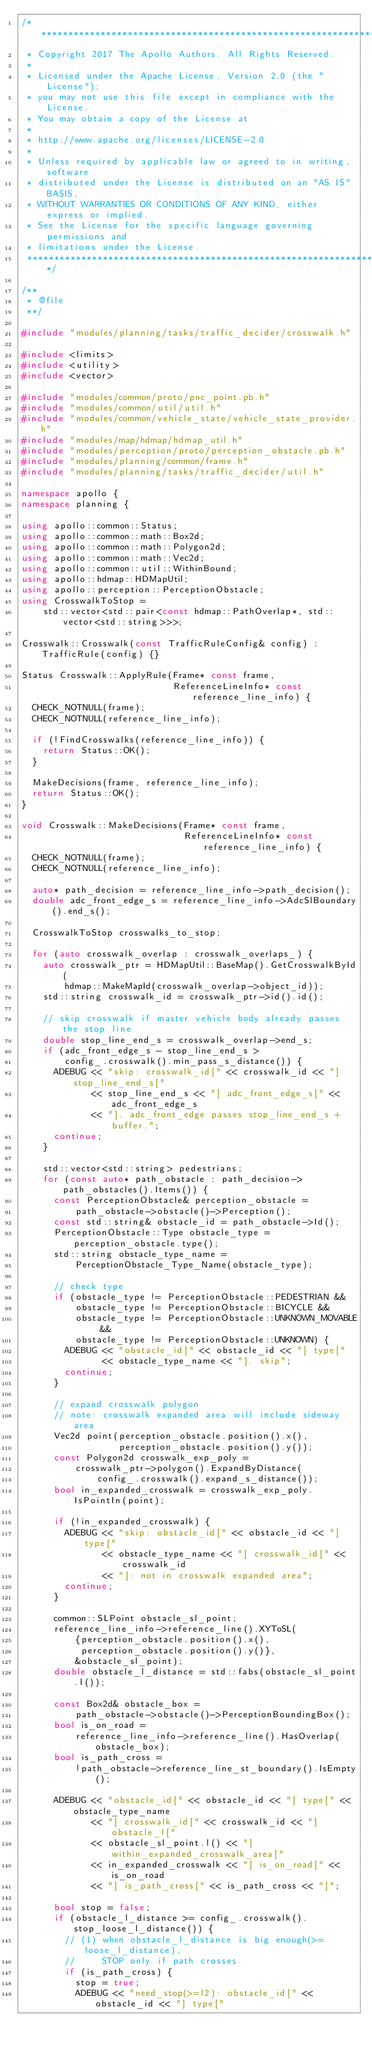Convert code to text. <code><loc_0><loc_0><loc_500><loc_500><_C++_>/******************************************************************************
 * Copyright 2017 The Apollo Authors. All Rights Reserved.
 *
 * Licensed under the Apache License, Version 2.0 (the "License");
 * you may not use this file except in compliance with the License.
 * You may obtain a copy of the License at
 *
 * http://www.apache.org/licenses/LICENSE-2.0
 *
 * Unless required by applicable law or agreed to in writing, software
 * distributed under the License is distributed on an "AS IS" BASIS,
 * WITHOUT WARRANTIES OR CONDITIONS OF ANY KIND, either express or implied.
 * See the License for the specific language governing permissions and
 * limitations under the License.
 *****************************************************************************/

/**
 * @file
 **/

#include "modules/planning/tasks/traffic_decider/crosswalk.h"

#include <limits>
#include <utility>
#include <vector>

#include "modules/common/proto/pnc_point.pb.h"
#include "modules/common/util/util.h"
#include "modules/common/vehicle_state/vehicle_state_provider.h"
#include "modules/map/hdmap/hdmap_util.h"
#include "modules/perception/proto/perception_obstacle.pb.h"
#include "modules/planning/common/frame.h"
#include "modules/planning/tasks/traffic_decider/util.h"

namespace apollo {
namespace planning {

using apollo::common::Status;
using apollo::common::math::Box2d;
using apollo::common::math::Polygon2d;
using apollo::common::math::Vec2d;
using apollo::common::util::WithinBound;
using apollo::hdmap::HDMapUtil;
using apollo::perception::PerceptionObstacle;
using CrosswalkToStop =
    std::vector<std::pair<const hdmap::PathOverlap*, std::vector<std::string>>>;

Crosswalk::Crosswalk(const TrafficRuleConfig& config) : TrafficRule(config) {}

Status Crosswalk::ApplyRule(Frame* const frame,
                            ReferenceLineInfo* const reference_line_info) {
  CHECK_NOTNULL(frame);
  CHECK_NOTNULL(reference_line_info);

  if (!FindCrosswalks(reference_line_info)) {
    return Status::OK();
  }

  MakeDecisions(frame, reference_line_info);
  return Status::OK();
}

void Crosswalk::MakeDecisions(Frame* const frame,
                              ReferenceLineInfo* const reference_line_info) {
  CHECK_NOTNULL(frame);
  CHECK_NOTNULL(reference_line_info);

  auto* path_decision = reference_line_info->path_decision();
  double adc_front_edge_s = reference_line_info->AdcSlBoundary().end_s();

  CrosswalkToStop crosswalks_to_stop;

  for (auto crosswalk_overlap : crosswalk_overlaps_) {
    auto crosswalk_ptr = HDMapUtil::BaseMap().GetCrosswalkById(
        hdmap::MakeMapId(crosswalk_overlap->object_id));
    std::string crosswalk_id = crosswalk_ptr->id().id();

    // skip crosswalk if master vehicle body already passes the stop line
    double stop_line_end_s = crosswalk_overlap->end_s;
    if (adc_front_edge_s - stop_line_end_s >
        config_.crosswalk().min_pass_s_distance()) {
      ADEBUG << "skip: crosswalk_id[" << crosswalk_id << "] stop_line_end_s["
             << stop_line_end_s << "] adc_front_edge_s[" << adc_front_edge_s
             << "]. adc_front_edge passes stop_line_end_s + buffer.";
      continue;
    }

    std::vector<std::string> pedestrians;
    for (const auto* path_obstacle : path_decision->path_obstacles().Items()) {
      const PerceptionObstacle& perception_obstacle =
          path_obstacle->obstacle()->Perception();
      const std::string& obstacle_id = path_obstacle->Id();
      PerceptionObstacle::Type obstacle_type = perception_obstacle.type();
      std::string obstacle_type_name =
          PerceptionObstacle_Type_Name(obstacle_type);

      // check type
      if (obstacle_type != PerceptionObstacle::PEDESTRIAN &&
          obstacle_type != PerceptionObstacle::BICYCLE &&
          obstacle_type != PerceptionObstacle::UNKNOWN_MOVABLE &&
          obstacle_type != PerceptionObstacle::UNKNOWN) {
        ADEBUG << "obstacle_id[" << obstacle_id << "] type["
               << obstacle_type_name << "]. skip";
        continue;
      }

      // expand crosswalk polygon
      // note: crosswalk expanded area will include sideway area
      Vec2d point(perception_obstacle.position().x(),
                  perception_obstacle.position().y());
      const Polygon2d crosswalk_exp_poly =
          crosswalk_ptr->polygon().ExpandByDistance(
              config_.crosswalk().expand_s_distance());
      bool in_expanded_crosswalk = crosswalk_exp_poly.IsPointIn(point);

      if (!in_expanded_crosswalk) {
        ADEBUG << "skip: obstacle_id[" << obstacle_id << "] type["
               << obstacle_type_name << "] crosswalk_id[" << crosswalk_id
               << "]: not in crosswalk expanded area";
        continue;
      }

      common::SLPoint obstacle_sl_point;
      reference_line_info->reference_line().XYToSL(
          {perception_obstacle.position().x(),
           perception_obstacle.position().y()},
          &obstacle_sl_point);
      double obstacle_l_distance = std::fabs(obstacle_sl_point.l());

      const Box2d& obstacle_box =
          path_obstacle->obstacle()->PerceptionBoundingBox();
      bool is_on_road =
          reference_line_info->reference_line().HasOverlap(obstacle_box);
      bool is_path_cross =
          !path_obstacle->reference_line_st_boundary().IsEmpty();

      ADEBUG << "obstacle_id[" << obstacle_id << "] type[" << obstacle_type_name
             << "] crosswalk_id[" << crosswalk_id << "] obstacle_l["
             << obstacle_sl_point.l() << "] within_expanded_crosswalk_area["
             << in_expanded_crosswalk << "] is_on_road[" << is_on_road
             << "] is_path_cross[" << is_path_cross << "]";

      bool stop = false;
      if (obstacle_l_distance >= config_.crosswalk().stop_loose_l_distance()) {
        // (1) when obstacle_l_distance is big enough(>= loose_l_distance),
        //     STOP only if path crosses
        if (is_path_cross) {
          stop = true;
          ADEBUG << "need_stop(>=l2): obstacle_id[" << obstacle_id << "] type["</code> 